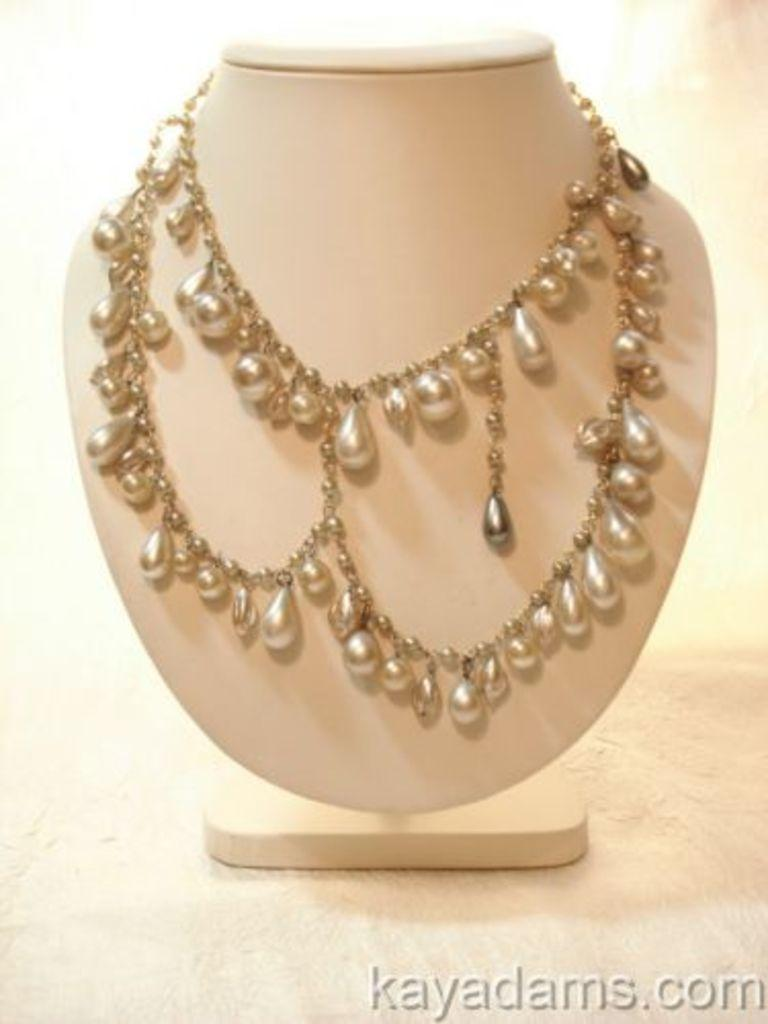What type of item is featured in the image? There is jewelry in the image. Where is the jewelry placed? The jewelry is placed on a plain surface. Is there any text present in the image? Yes, there is text visible at the bottom of the image. What is the rate of the pencil in the image? There is no pencil present in the image, so it is not possible to determine a rate. 